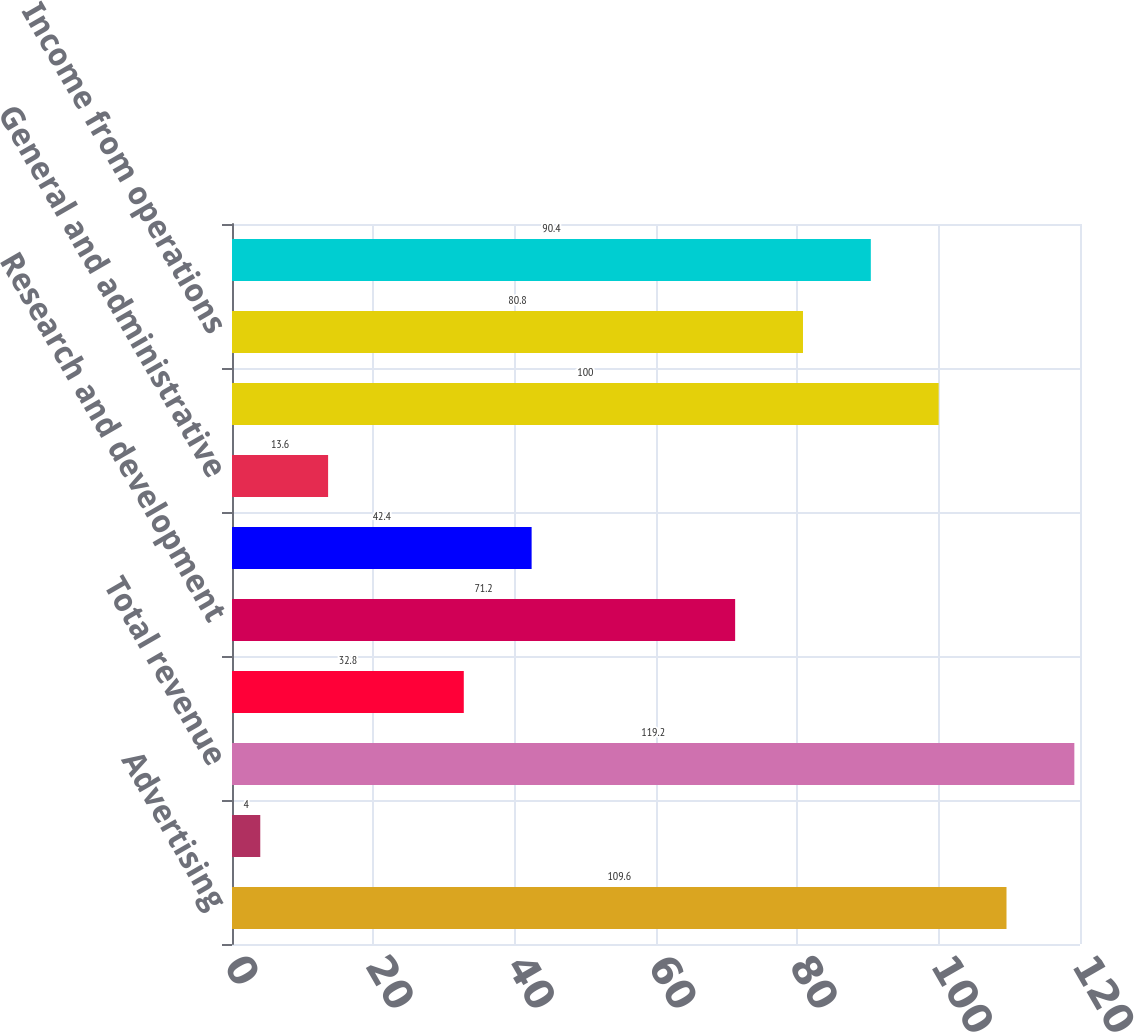<chart> <loc_0><loc_0><loc_500><loc_500><bar_chart><fcel>Advertising<fcel>Payments and other fees<fcel>Total revenue<fcel>Cost of revenue<fcel>Research and development<fcel>Marketing and sales<fcel>General and administrative<fcel>Total costs and expenses<fcel>Income from operations<fcel>Income before provision for<nl><fcel>109.6<fcel>4<fcel>119.2<fcel>32.8<fcel>71.2<fcel>42.4<fcel>13.6<fcel>100<fcel>80.8<fcel>90.4<nl></chart> 